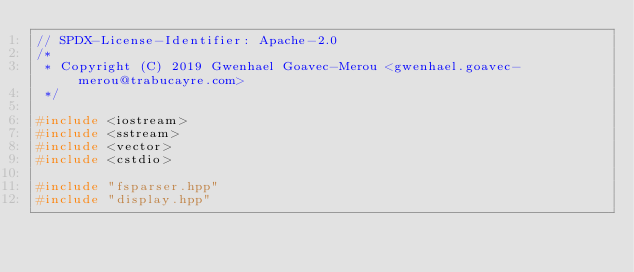<code> <loc_0><loc_0><loc_500><loc_500><_C++_>// SPDX-License-Identifier: Apache-2.0
/*
 * Copyright (C) 2019 Gwenhael Goavec-Merou <gwenhael.goavec-merou@trabucayre.com>
 */

#include <iostream>
#include <sstream>
#include <vector>
#include <cstdio>

#include "fsparser.hpp"
#include "display.hpp"
</code> 